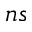<formula> <loc_0><loc_0><loc_500><loc_500>n s</formula> 